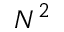<formula> <loc_0><loc_0><loc_500><loc_500>N ^ { 2 }</formula> 